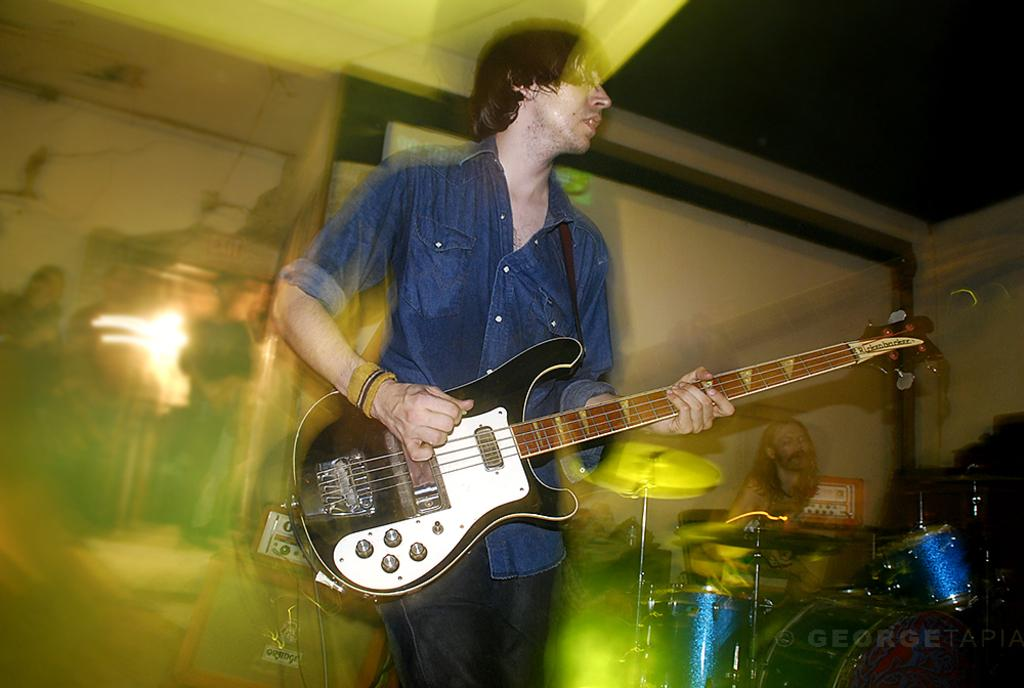What is the man in the image wearing? The man is wearing a blue shirt in the image. What is the man doing in the image? The man is playing a guitar in the image. Can you describe the other person in the image? There is a person sitting on a chair and playing musical instruments in the image. How are the persons positioned in the image? The persons are standing in the image. What object can be seen with a device on it in the image? There is a box with a device on it in the image. What type of quill is the man using to play the guitar in the image? There is no quill present in the image; the man is playing a guitar with his hands. 